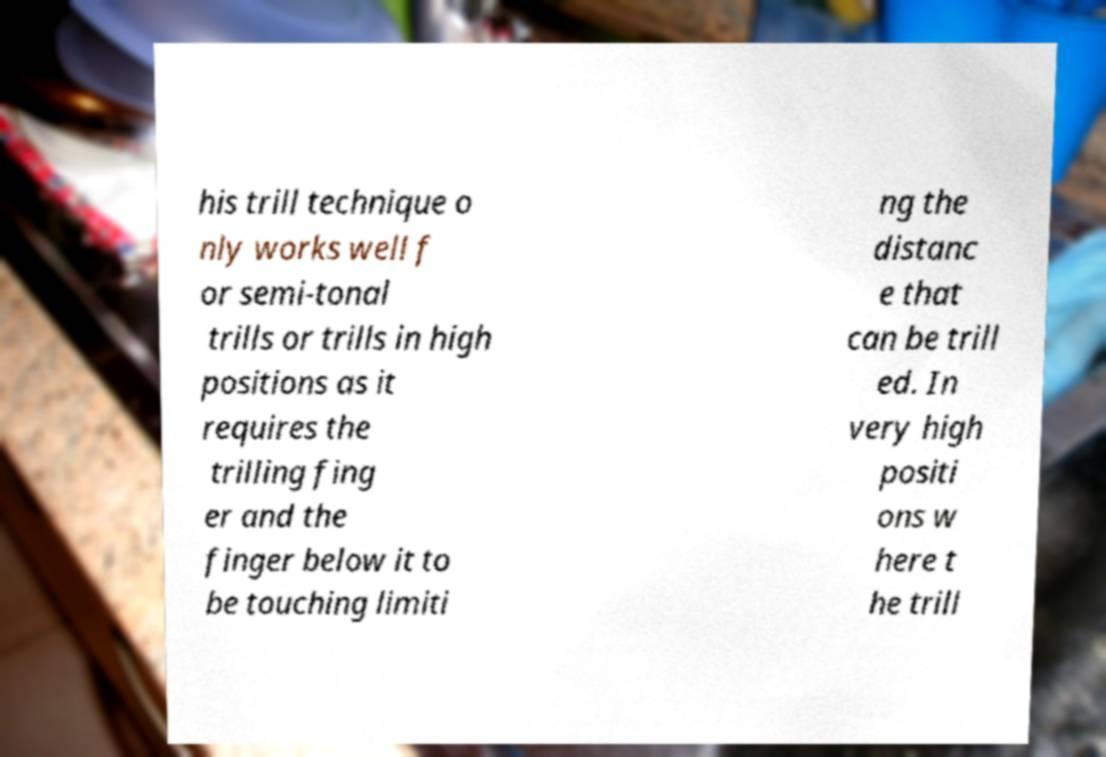There's text embedded in this image that I need extracted. Can you transcribe it verbatim? his trill technique o nly works well f or semi-tonal trills or trills in high positions as it requires the trilling fing er and the finger below it to be touching limiti ng the distanc e that can be trill ed. In very high positi ons w here t he trill 